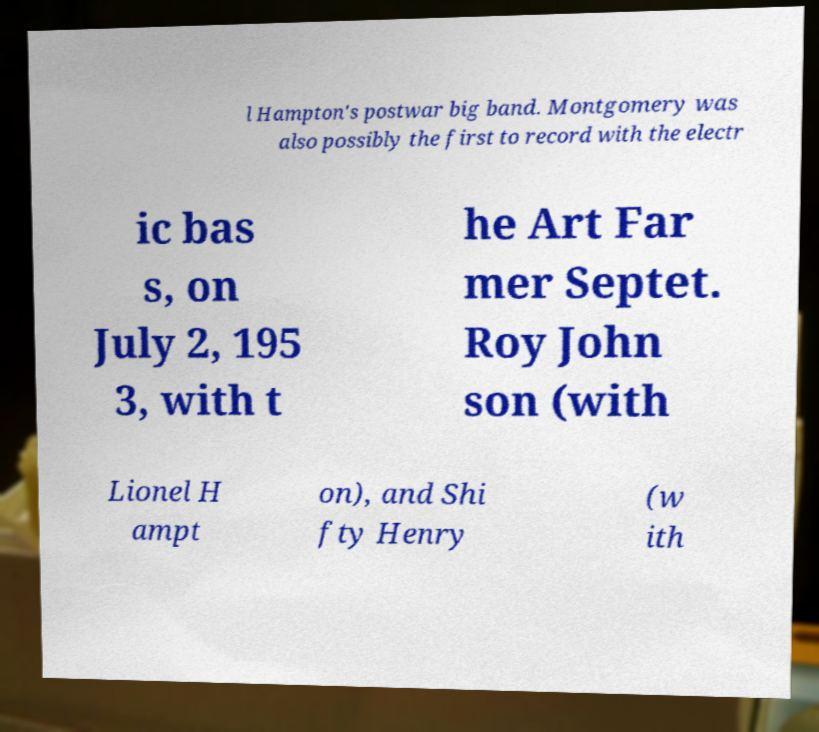I need the written content from this picture converted into text. Can you do that? l Hampton's postwar big band. Montgomery was also possibly the first to record with the electr ic bas s, on July 2, 195 3, with t he Art Far mer Septet. Roy John son (with Lionel H ampt on), and Shi fty Henry (w ith 